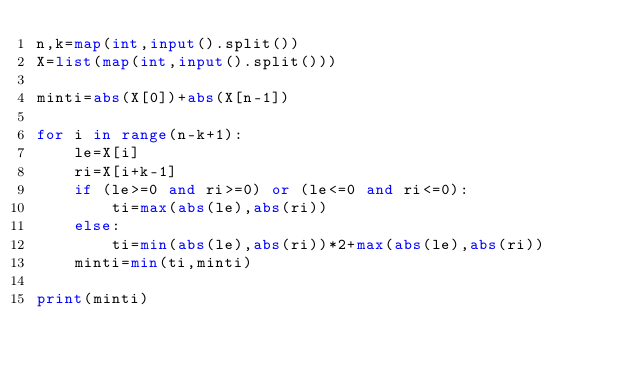Convert code to text. <code><loc_0><loc_0><loc_500><loc_500><_Python_>n,k=map(int,input().split())
X=list(map(int,input().split()))

minti=abs(X[0])+abs(X[n-1])

for i in range(n-k+1):
    le=X[i]
    ri=X[i+k-1]
    if (le>=0 and ri>=0) or (le<=0 and ri<=0):
        ti=max(abs(le),abs(ri))
    else:
        ti=min(abs(le),abs(ri))*2+max(abs(le),abs(ri))
    minti=min(ti,minti)

print(minti)
</code> 